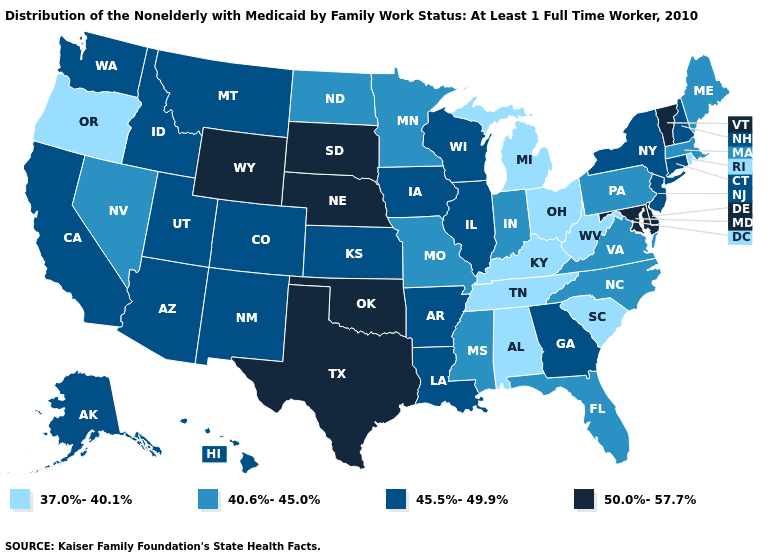Name the states that have a value in the range 37.0%-40.1%?
Be succinct. Alabama, Kentucky, Michigan, Ohio, Oregon, Rhode Island, South Carolina, Tennessee, West Virginia. Which states hav the highest value in the MidWest?
Quick response, please. Nebraska, South Dakota. Is the legend a continuous bar?
Quick response, please. No. What is the highest value in the West ?
Write a very short answer. 50.0%-57.7%. What is the highest value in the USA?
Short answer required. 50.0%-57.7%. Name the states that have a value in the range 45.5%-49.9%?
Quick response, please. Alaska, Arizona, Arkansas, California, Colorado, Connecticut, Georgia, Hawaii, Idaho, Illinois, Iowa, Kansas, Louisiana, Montana, New Hampshire, New Jersey, New Mexico, New York, Utah, Washington, Wisconsin. Name the states that have a value in the range 40.6%-45.0%?
Be succinct. Florida, Indiana, Maine, Massachusetts, Minnesota, Mississippi, Missouri, Nevada, North Carolina, North Dakota, Pennsylvania, Virginia. What is the value of Utah?
Be succinct. 45.5%-49.9%. Which states hav the highest value in the South?
Short answer required. Delaware, Maryland, Oklahoma, Texas. Name the states that have a value in the range 37.0%-40.1%?
Write a very short answer. Alabama, Kentucky, Michigan, Ohio, Oregon, Rhode Island, South Carolina, Tennessee, West Virginia. Name the states that have a value in the range 40.6%-45.0%?
Concise answer only. Florida, Indiana, Maine, Massachusetts, Minnesota, Mississippi, Missouri, Nevada, North Carolina, North Dakota, Pennsylvania, Virginia. What is the value of Michigan?
Write a very short answer. 37.0%-40.1%. Does Nebraska have the same value as New Hampshire?
Write a very short answer. No. Among the states that border New Mexico , does Arizona have the lowest value?
Give a very brief answer. Yes. 